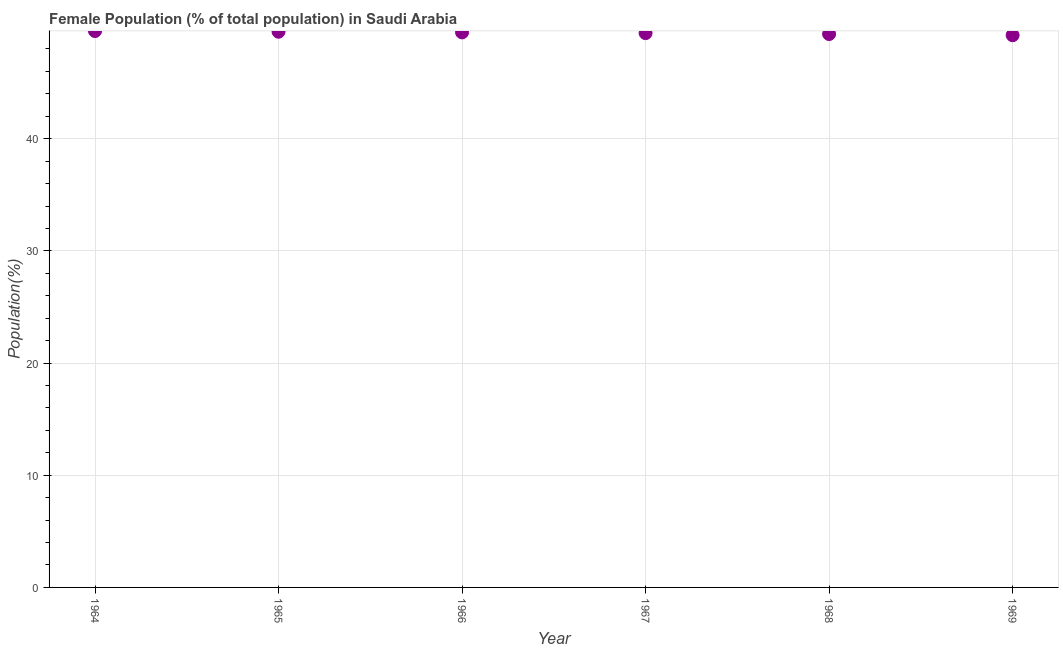What is the female population in 1964?
Ensure brevity in your answer.  49.6. Across all years, what is the maximum female population?
Offer a terse response. 49.6. Across all years, what is the minimum female population?
Keep it short and to the point. 49.22. In which year was the female population maximum?
Keep it short and to the point. 1964. In which year was the female population minimum?
Provide a succinct answer. 1969. What is the sum of the female population?
Ensure brevity in your answer.  296.58. What is the difference between the female population in 1964 and 1966?
Your response must be concise. 0.12. What is the average female population per year?
Your answer should be very brief. 49.43. What is the median female population?
Ensure brevity in your answer.  49.44. In how many years, is the female population greater than 34 %?
Keep it short and to the point. 6. What is the ratio of the female population in 1967 to that in 1968?
Provide a short and direct response. 1. Is the female population in 1965 less than that in 1968?
Provide a succinct answer. No. What is the difference between the highest and the second highest female population?
Offer a very short reply. 0.06. Is the sum of the female population in 1966 and 1969 greater than the maximum female population across all years?
Your response must be concise. Yes. What is the difference between the highest and the lowest female population?
Provide a succinct answer. 0.37. Does the female population monotonically increase over the years?
Ensure brevity in your answer.  No. Are the values on the major ticks of Y-axis written in scientific E-notation?
Provide a succinct answer. No. What is the title of the graph?
Give a very brief answer. Female Population (% of total population) in Saudi Arabia. What is the label or title of the Y-axis?
Provide a succinct answer. Population(%). What is the Population(%) in 1964?
Offer a terse response. 49.6. What is the Population(%) in 1965?
Give a very brief answer. 49.54. What is the Population(%) in 1966?
Give a very brief answer. 49.48. What is the Population(%) in 1967?
Provide a short and direct response. 49.41. What is the Population(%) in 1968?
Ensure brevity in your answer.  49.33. What is the Population(%) in 1969?
Give a very brief answer. 49.22. What is the difference between the Population(%) in 1964 and 1965?
Your response must be concise. 0.06. What is the difference between the Population(%) in 1964 and 1966?
Offer a very short reply. 0.12. What is the difference between the Population(%) in 1964 and 1967?
Ensure brevity in your answer.  0.19. What is the difference between the Population(%) in 1964 and 1968?
Give a very brief answer. 0.27. What is the difference between the Population(%) in 1964 and 1969?
Provide a short and direct response. 0.37. What is the difference between the Population(%) in 1965 and 1966?
Ensure brevity in your answer.  0.06. What is the difference between the Population(%) in 1965 and 1967?
Keep it short and to the point. 0.13. What is the difference between the Population(%) in 1965 and 1968?
Give a very brief answer. 0.21. What is the difference between the Population(%) in 1965 and 1969?
Offer a terse response. 0.31. What is the difference between the Population(%) in 1966 and 1967?
Your answer should be compact. 0.07. What is the difference between the Population(%) in 1966 and 1968?
Your answer should be compact. 0.15. What is the difference between the Population(%) in 1966 and 1969?
Your answer should be compact. 0.25. What is the difference between the Population(%) in 1967 and 1968?
Your answer should be compact. 0.08. What is the difference between the Population(%) in 1967 and 1969?
Your response must be concise. 0.19. What is the difference between the Population(%) in 1968 and 1969?
Offer a terse response. 0.11. What is the ratio of the Population(%) in 1968 to that in 1969?
Provide a succinct answer. 1. 